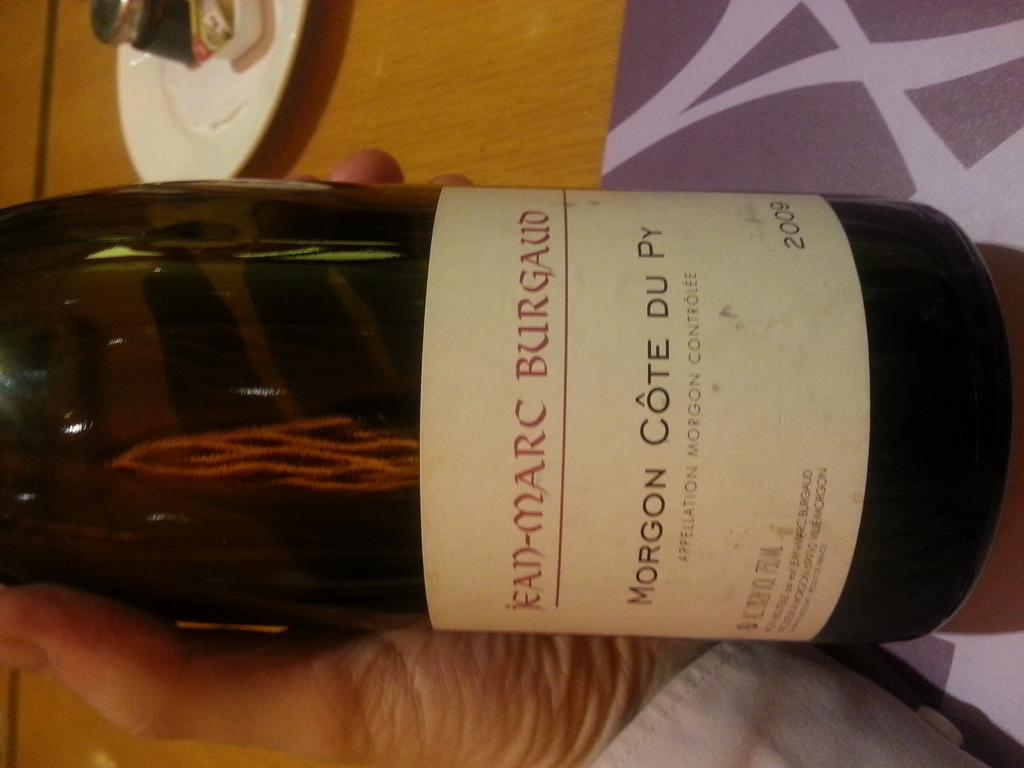<image>
Summarize the visual content of the image. Someone holding a bottle of Morgon Cote Du over the table 